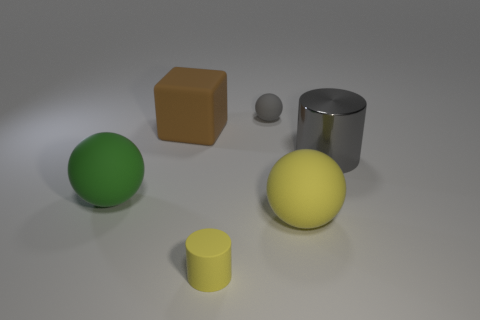How many other things are there of the same color as the big rubber cube?
Your answer should be very brief. 0. What number of large things have the same color as the small matte cylinder?
Keep it short and to the point. 1. There is another big rubber object that is the same shape as the large green rubber thing; what color is it?
Your answer should be very brief. Yellow. There is a large thing that is on the right side of the small gray rubber object and in front of the gray metallic thing; what shape is it?
Offer a terse response. Sphere. Are there more big green spheres than balls?
Provide a succinct answer. No. What material is the small yellow cylinder?
Make the answer very short. Rubber. What size is the other yellow object that is the same shape as the metal object?
Offer a terse response. Small. Are there any gray cylinders that are behind the tiny thing that is in front of the large rubber block?
Provide a short and direct response. Yes. Do the metal cylinder and the tiny matte sphere have the same color?
Your response must be concise. Yes. How many other objects are the same shape as the small gray rubber object?
Make the answer very short. 2. 